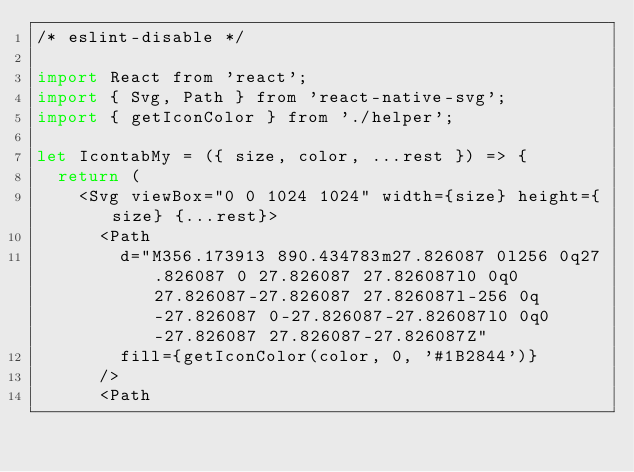Convert code to text. <code><loc_0><loc_0><loc_500><loc_500><_JavaScript_>/* eslint-disable */

import React from 'react';
import { Svg, Path } from 'react-native-svg';
import { getIconColor } from './helper';

let IcontabMy = ({ size, color, ...rest }) => {
  return (
    <Svg viewBox="0 0 1024 1024" width={size} height={size} {...rest}>
      <Path
        d="M356.173913 890.434783m27.826087 0l256 0q27.826087 0 27.826087 27.826087l0 0q0 27.826087-27.826087 27.826087l-256 0q-27.826087 0-27.826087-27.826087l0 0q0-27.826087 27.826087-27.826087Z"
        fill={getIconColor(color, 0, '#1B2844')}
      />
      <Path</code> 